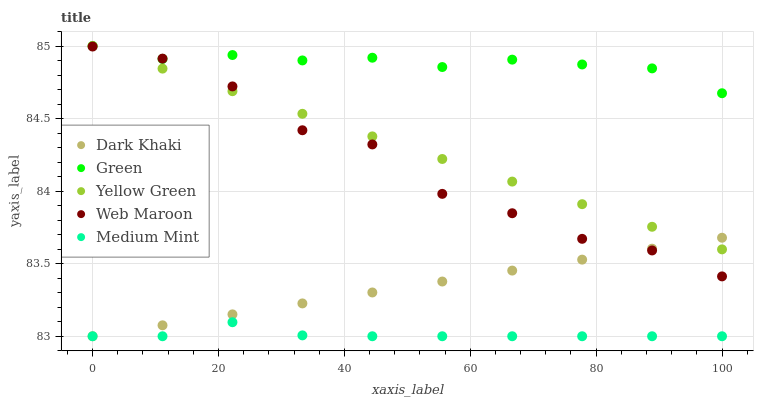Does Medium Mint have the minimum area under the curve?
Answer yes or no. Yes. Does Green have the maximum area under the curve?
Answer yes or no. Yes. Does Web Maroon have the minimum area under the curve?
Answer yes or no. No. Does Web Maroon have the maximum area under the curve?
Answer yes or no. No. Is Dark Khaki the smoothest?
Answer yes or no. Yes. Is Web Maroon the roughest?
Answer yes or no. Yes. Is Green the smoothest?
Answer yes or no. No. Is Green the roughest?
Answer yes or no. No. Does Dark Khaki have the lowest value?
Answer yes or no. Yes. Does Web Maroon have the lowest value?
Answer yes or no. No. Does Yellow Green have the highest value?
Answer yes or no. Yes. Does Web Maroon have the highest value?
Answer yes or no. No. Is Medium Mint less than Web Maroon?
Answer yes or no. Yes. Is Green greater than Dark Khaki?
Answer yes or no. Yes. Does Dark Khaki intersect Yellow Green?
Answer yes or no. Yes. Is Dark Khaki less than Yellow Green?
Answer yes or no. No. Is Dark Khaki greater than Yellow Green?
Answer yes or no. No. Does Medium Mint intersect Web Maroon?
Answer yes or no. No. 